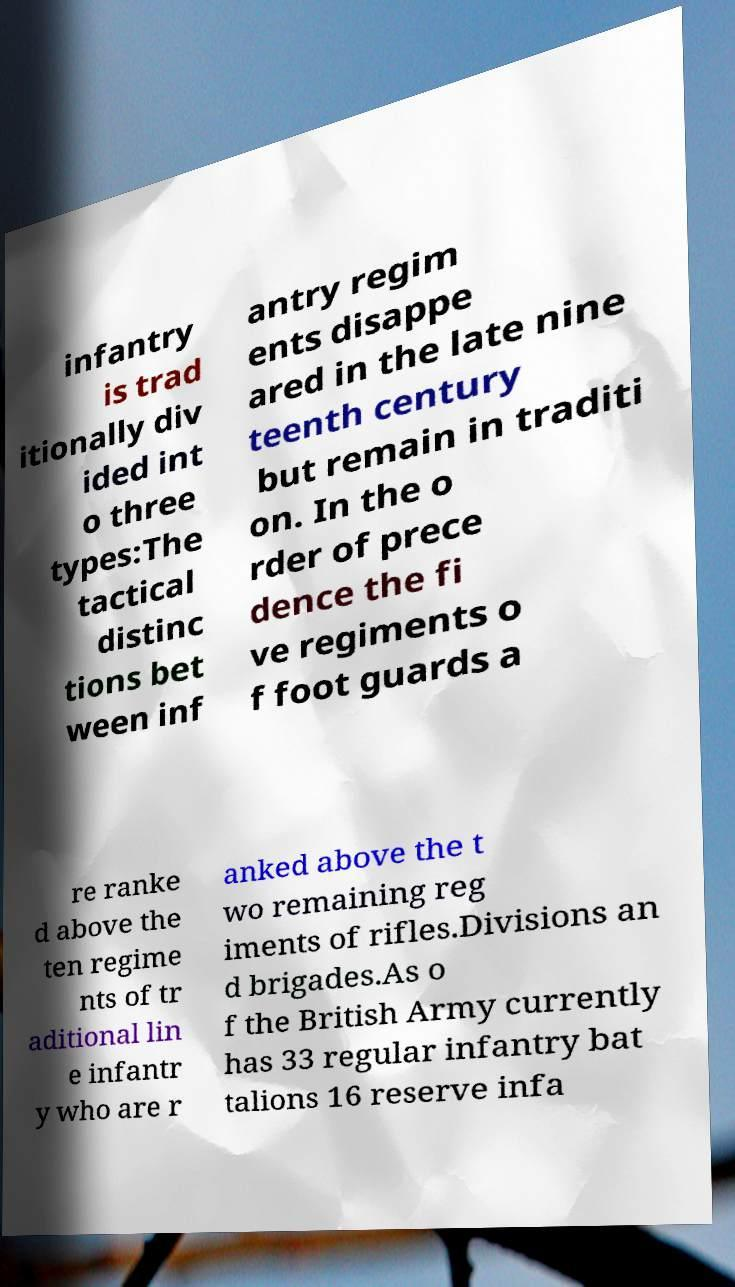For documentation purposes, I need the text within this image transcribed. Could you provide that? infantry is trad itionally div ided int o three types:The tactical distinc tions bet ween inf antry regim ents disappe ared in the late nine teenth century but remain in traditi on. In the o rder of prece dence the fi ve regiments o f foot guards a re ranke d above the ten regime nts of tr aditional lin e infantr y who are r anked above the t wo remaining reg iments of rifles.Divisions an d brigades.As o f the British Army currently has 33 regular infantry bat talions 16 reserve infa 